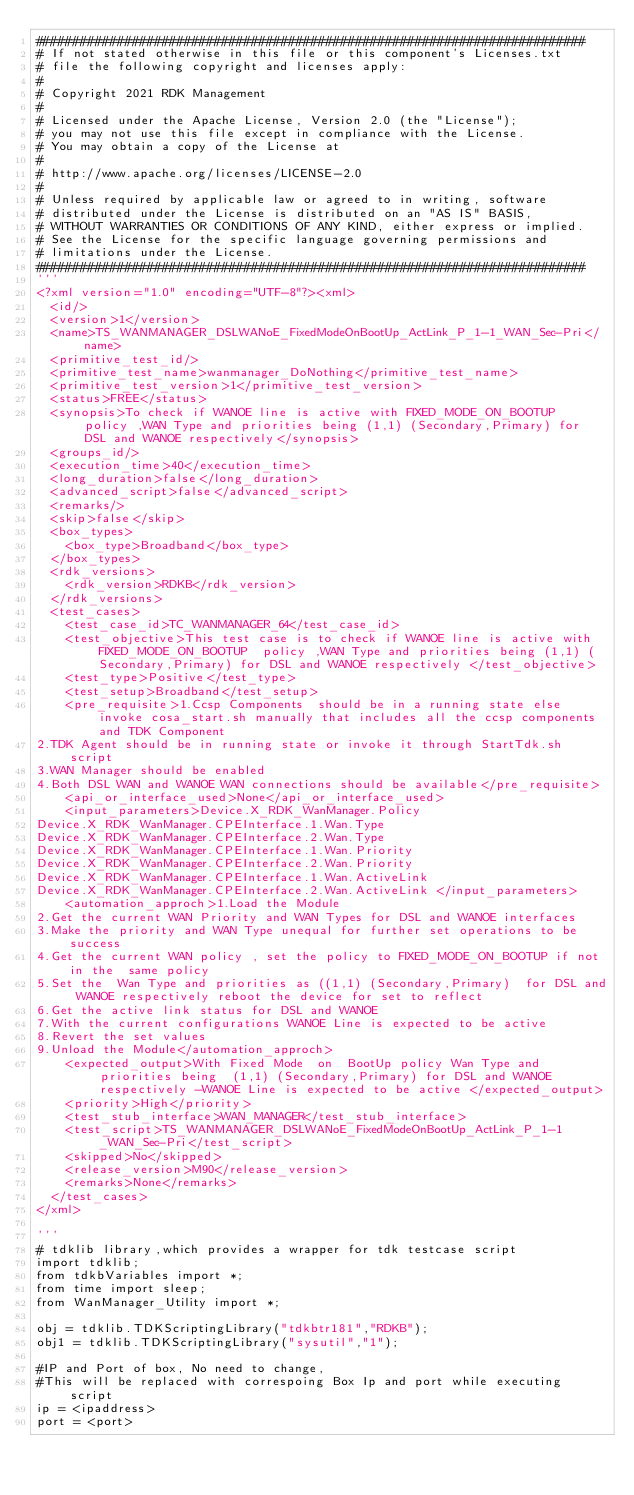<code> <loc_0><loc_0><loc_500><loc_500><_Python_>##########################################################################
# If not stated otherwise in this file or this component's Licenses.txt
# file the following copyright and licenses apply:
#
# Copyright 2021 RDK Management
#
# Licensed under the Apache License, Version 2.0 (the "License");
# you may not use this file except in compliance with the License.
# You may obtain a copy of the License at
#
# http://www.apache.org/licenses/LICENSE-2.0
#
# Unless required by applicable law or agreed to in writing, software
# distributed under the License is distributed on an "AS IS" BASIS,
# WITHOUT WARRANTIES OR CONDITIONS OF ANY KIND, either express or implied.
# See the License for the specific language governing permissions and
# limitations under the License.
##########################################################################
'''
<?xml version="1.0" encoding="UTF-8"?><xml>
  <id/>
  <version>1</version>
  <name>TS_WANMANAGER_DSLWANoE_FixedModeOnBootUp_ActLink_P_1-1_WAN_Sec-Pri</name>
  <primitive_test_id/>
  <primitive_test_name>wanmanager_DoNothing</primitive_test_name>
  <primitive_test_version>1</primitive_test_version>
  <status>FREE</status>
  <synopsis>To check if WANOE line is active with FIXED_MODE_ON_BOOTUP  policy ,WAN Type and priorities being (1,1) (Secondary,Primary) for DSL and WANOE respectively</synopsis>
  <groups_id/>
  <execution_time>40</execution_time>
  <long_duration>false</long_duration>
  <advanced_script>false</advanced_script>
  <remarks/>
  <skip>false</skip>
  <box_types>
    <box_type>Broadband</box_type>
  </box_types>
  <rdk_versions>
    <rdk_version>RDKB</rdk_version>
  </rdk_versions>
  <test_cases>
    <test_case_id>TC_WANMANAGER_64</test_case_id>
    <test_objective>This test case is to check if WANOE line is active with FIXED_MODE_ON_BOOTUP  policy ,WAN Type and priorities being (1,1) (Secondary,Primary) for DSL and WANOE respectively </test_objective>
    <test_type>Positive</test_type>
    <test_setup>Broadband</test_setup>
    <pre_requisite>1.Ccsp Components  should be in a running state else invoke cosa_start.sh manually that includes all the ccsp components and TDK Component
2.TDK Agent should be in running state or invoke it through StartTdk.sh script
3.WAN Manager should be enabled
4.Both DSL WAN and WANOE WAN connections should be available</pre_requisite>
    <api_or_interface_used>None</api_or_interface_used>
    <input_parameters>Device.X_RDK_WanManager.Policy 
Device.X_RDK_WanManager.CPEInterface.1.Wan.Type
Device.X_RDK_WanManager.CPEInterface.2.Wan.Type 
Device.X_RDK_WanManager.CPEInterface.1.Wan.Priority 
Device.X_RDK_WanManager.CPEInterface.2.Wan.Priority
Device.X_RDK_WanManager.CPEInterface.1.Wan.ActiveLink
Device.X_RDK_WanManager.CPEInterface.2.Wan.ActiveLink </input_parameters>
    <automation_approch>1.Load the Module
2.Get the current WAN Priority and WAN Types for DSL and WANOE interfaces
3.Make the priority and WAN Type unequal for further set operations to be success 
4.Get the current WAN policy , set the policy to FIXED_MODE_ON_BOOTUP if not in the  same policy
5.Set the  Wan Type and priorities as ((1,1) (Secondary,Primary)  for DSL and WANOE respectively reboot the device for set to reflect
6.Get the active link status for DSL and WANOE
7.With the current configurations WANOE Line is expected to be active
8.Revert the set values
9.Unload the Module</automation_approch>
    <expected_output>With Fixed Mode  on  BootUp policy Wan Type and priorities being  (1,1) (Secondary,Primary) for DSL and WANOE respectively -WANOE Line is expected to be active </expected_output>
    <priority>High</priority>
    <test_stub_interface>WAN_MANAGER</test_stub_interface>
    <test_script>TS_WANMANAGER_DSLWANoE_FixedModeOnBootUp_ActLink_P_1-1_WAN_Sec-Pri</test_script>
    <skipped>No</skipped>
    <release_version>M90</release_version>
    <remarks>None</remarks>
  </test_cases>
</xml>

'''
# tdklib library,which provides a wrapper for tdk testcase script
import tdklib;
from tdkbVariables import *;
from time import sleep;
from WanManager_Utility import *;

obj = tdklib.TDKScriptingLibrary("tdkbtr181","RDKB");
obj1 = tdklib.TDKScriptingLibrary("sysutil","1");

#IP and Port of box, No need to change,
#This will be replaced with correspoing Box Ip and port while executing script
ip = <ipaddress>
port = <port></code> 